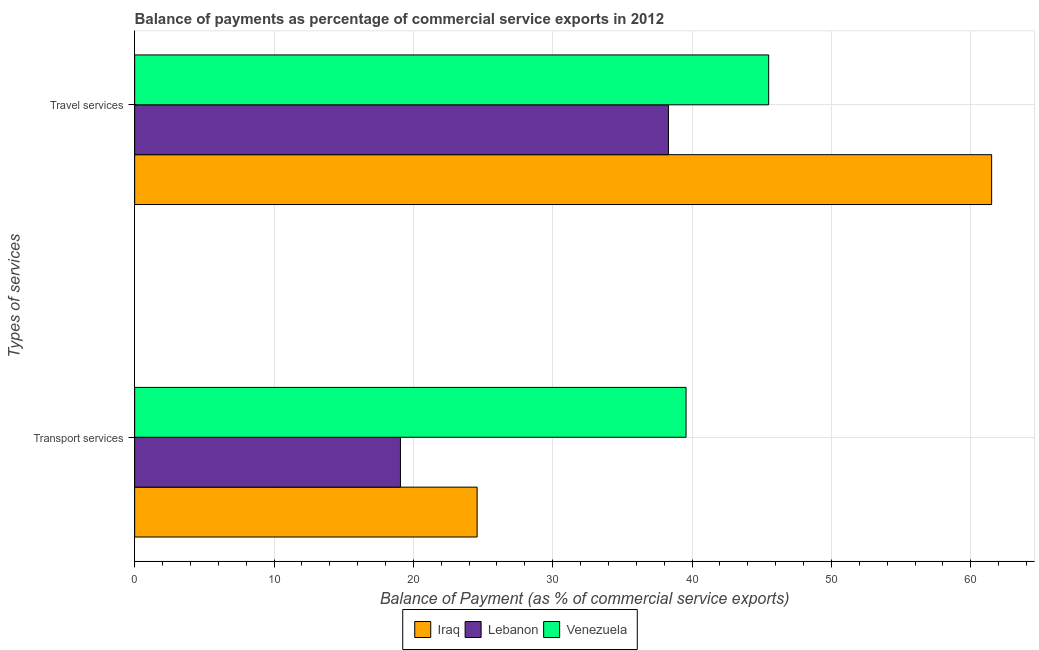How many groups of bars are there?
Your answer should be compact. 2. What is the label of the 2nd group of bars from the top?
Your answer should be compact. Transport services. What is the balance of payments of transport services in Iraq?
Offer a very short reply. 24.58. Across all countries, what is the maximum balance of payments of transport services?
Offer a terse response. 39.57. Across all countries, what is the minimum balance of payments of transport services?
Give a very brief answer. 19.07. In which country was the balance of payments of transport services maximum?
Make the answer very short. Venezuela. In which country was the balance of payments of travel services minimum?
Make the answer very short. Lebanon. What is the total balance of payments of travel services in the graph?
Provide a short and direct response. 145.3. What is the difference between the balance of payments of travel services in Venezuela and that in Lebanon?
Ensure brevity in your answer.  7.19. What is the difference between the balance of payments of transport services in Venezuela and the balance of payments of travel services in Iraq?
Ensure brevity in your answer.  -21.93. What is the average balance of payments of travel services per country?
Ensure brevity in your answer.  48.43. What is the difference between the balance of payments of travel services and balance of payments of transport services in Venezuela?
Your answer should be very brief. 5.93. What is the ratio of the balance of payments of transport services in Venezuela to that in Iraq?
Your answer should be compact. 1.61. What does the 3rd bar from the top in Transport services represents?
Give a very brief answer. Iraq. What does the 2nd bar from the bottom in Travel services represents?
Offer a very short reply. Lebanon. How many countries are there in the graph?
Offer a terse response. 3. What is the difference between two consecutive major ticks on the X-axis?
Give a very brief answer. 10. Are the values on the major ticks of X-axis written in scientific E-notation?
Make the answer very short. No. Does the graph contain grids?
Your answer should be compact. Yes. How many legend labels are there?
Provide a short and direct response. 3. How are the legend labels stacked?
Provide a short and direct response. Horizontal. What is the title of the graph?
Provide a short and direct response. Balance of payments as percentage of commercial service exports in 2012. Does "Lao PDR" appear as one of the legend labels in the graph?
Ensure brevity in your answer.  No. What is the label or title of the X-axis?
Offer a terse response. Balance of Payment (as % of commercial service exports). What is the label or title of the Y-axis?
Make the answer very short. Types of services. What is the Balance of Payment (as % of commercial service exports) of Iraq in Transport services?
Your answer should be compact. 24.58. What is the Balance of Payment (as % of commercial service exports) of Lebanon in Transport services?
Ensure brevity in your answer.  19.07. What is the Balance of Payment (as % of commercial service exports) in Venezuela in Transport services?
Your response must be concise. 39.57. What is the Balance of Payment (as % of commercial service exports) of Iraq in Travel services?
Keep it short and to the point. 61.5. What is the Balance of Payment (as % of commercial service exports) of Lebanon in Travel services?
Offer a very short reply. 38.31. What is the Balance of Payment (as % of commercial service exports) in Venezuela in Travel services?
Your answer should be compact. 45.5. Across all Types of services, what is the maximum Balance of Payment (as % of commercial service exports) in Iraq?
Your response must be concise. 61.5. Across all Types of services, what is the maximum Balance of Payment (as % of commercial service exports) of Lebanon?
Offer a terse response. 38.31. Across all Types of services, what is the maximum Balance of Payment (as % of commercial service exports) of Venezuela?
Make the answer very short. 45.5. Across all Types of services, what is the minimum Balance of Payment (as % of commercial service exports) of Iraq?
Your response must be concise. 24.58. Across all Types of services, what is the minimum Balance of Payment (as % of commercial service exports) of Lebanon?
Keep it short and to the point. 19.07. Across all Types of services, what is the minimum Balance of Payment (as % of commercial service exports) of Venezuela?
Make the answer very short. 39.57. What is the total Balance of Payment (as % of commercial service exports) of Iraq in the graph?
Your response must be concise. 86.07. What is the total Balance of Payment (as % of commercial service exports) of Lebanon in the graph?
Provide a succinct answer. 57.38. What is the total Balance of Payment (as % of commercial service exports) in Venezuela in the graph?
Give a very brief answer. 85.07. What is the difference between the Balance of Payment (as % of commercial service exports) in Iraq in Transport services and that in Travel services?
Keep it short and to the point. -36.92. What is the difference between the Balance of Payment (as % of commercial service exports) of Lebanon in Transport services and that in Travel services?
Your answer should be compact. -19.23. What is the difference between the Balance of Payment (as % of commercial service exports) in Venezuela in Transport services and that in Travel services?
Provide a short and direct response. -5.93. What is the difference between the Balance of Payment (as % of commercial service exports) in Iraq in Transport services and the Balance of Payment (as % of commercial service exports) in Lebanon in Travel services?
Keep it short and to the point. -13.73. What is the difference between the Balance of Payment (as % of commercial service exports) in Iraq in Transport services and the Balance of Payment (as % of commercial service exports) in Venezuela in Travel services?
Your response must be concise. -20.92. What is the difference between the Balance of Payment (as % of commercial service exports) of Lebanon in Transport services and the Balance of Payment (as % of commercial service exports) of Venezuela in Travel services?
Give a very brief answer. -26.42. What is the average Balance of Payment (as % of commercial service exports) in Iraq per Types of services?
Your answer should be compact. 43.04. What is the average Balance of Payment (as % of commercial service exports) of Lebanon per Types of services?
Provide a succinct answer. 28.69. What is the average Balance of Payment (as % of commercial service exports) of Venezuela per Types of services?
Ensure brevity in your answer.  42.53. What is the difference between the Balance of Payment (as % of commercial service exports) in Iraq and Balance of Payment (as % of commercial service exports) in Lebanon in Transport services?
Give a very brief answer. 5.5. What is the difference between the Balance of Payment (as % of commercial service exports) in Iraq and Balance of Payment (as % of commercial service exports) in Venezuela in Transport services?
Provide a short and direct response. -14.99. What is the difference between the Balance of Payment (as % of commercial service exports) of Lebanon and Balance of Payment (as % of commercial service exports) of Venezuela in Transport services?
Give a very brief answer. -20.49. What is the difference between the Balance of Payment (as % of commercial service exports) of Iraq and Balance of Payment (as % of commercial service exports) of Lebanon in Travel services?
Your answer should be compact. 23.19. What is the difference between the Balance of Payment (as % of commercial service exports) in Iraq and Balance of Payment (as % of commercial service exports) in Venezuela in Travel services?
Your response must be concise. 16. What is the difference between the Balance of Payment (as % of commercial service exports) of Lebanon and Balance of Payment (as % of commercial service exports) of Venezuela in Travel services?
Offer a terse response. -7.19. What is the ratio of the Balance of Payment (as % of commercial service exports) in Iraq in Transport services to that in Travel services?
Ensure brevity in your answer.  0.4. What is the ratio of the Balance of Payment (as % of commercial service exports) in Lebanon in Transport services to that in Travel services?
Offer a terse response. 0.5. What is the ratio of the Balance of Payment (as % of commercial service exports) of Venezuela in Transport services to that in Travel services?
Offer a terse response. 0.87. What is the difference between the highest and the second highest Balance of Payment (as % of commercial service exports) of Iraq?
Offer a terse response. 36.92. What is the difference between the highest and the second highest Balance of Payment (as % of commercial service exports) in Lebanon?
Provide a short and direct response. 19.23. What is the difference between the highest and the second highest Balance of Payment (as % of commercial service exports) of Venezuela?
Keep it short and to the point. 5.93. What is the difference between the highest and the lowest Balance of Payment (as % of commercial service exports) of Iraq?
Offer a very short reply. 36.92. What is the difference between the highest and the lowest Balance of Payment (as % of commercial service exports) in Lebanon?
Provide a succinct answer. 19.23. What is the difference between the highest and the lowest Balance of Payment (as % of commercial service exports) in Venezuela?
Your answer should be very brief. 5.93. 